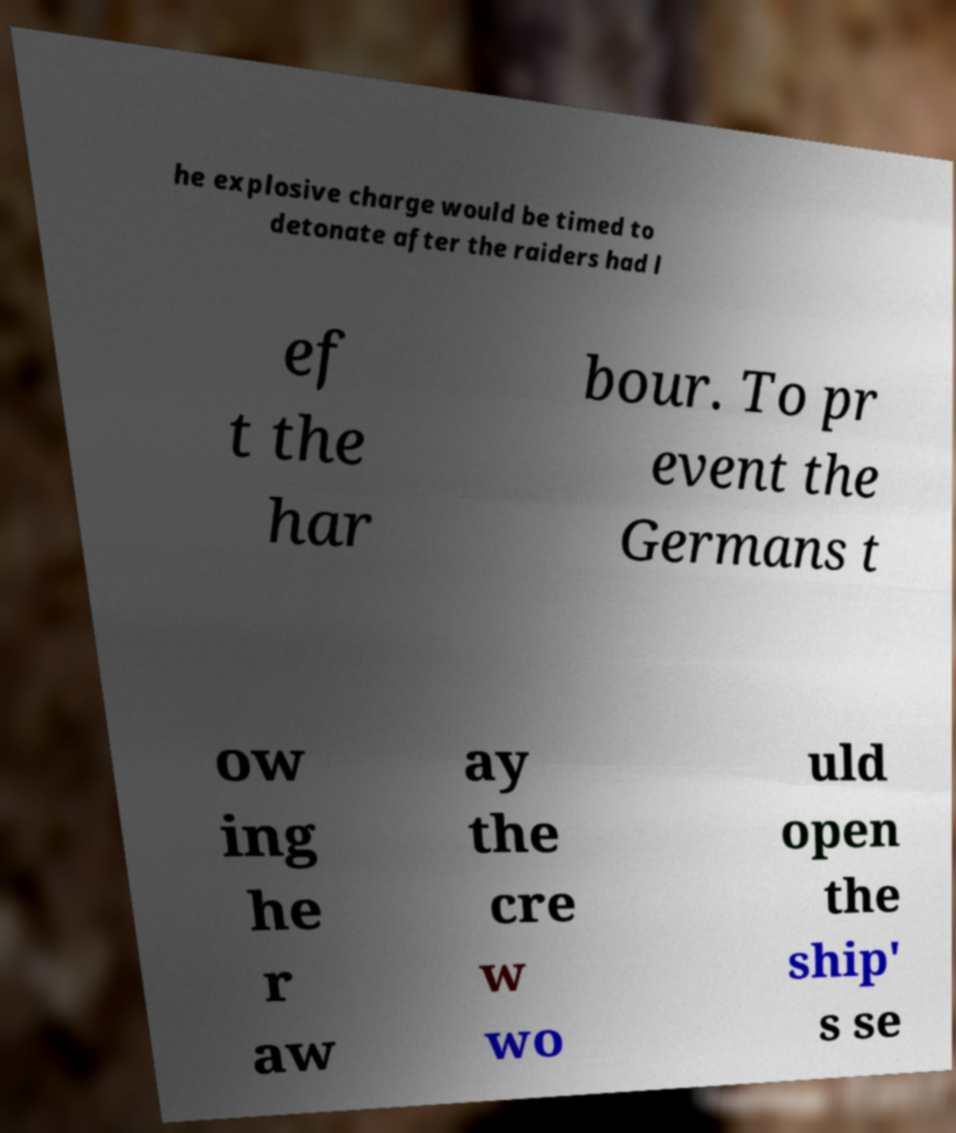Please read and relay the text visible in this image. What does it say? he explosive charge would be timed to detonate after the raiders had l ef t the har bour. To pr event the Germans t ow ing he r aw ay the cre w wo uld open the ship' s se 